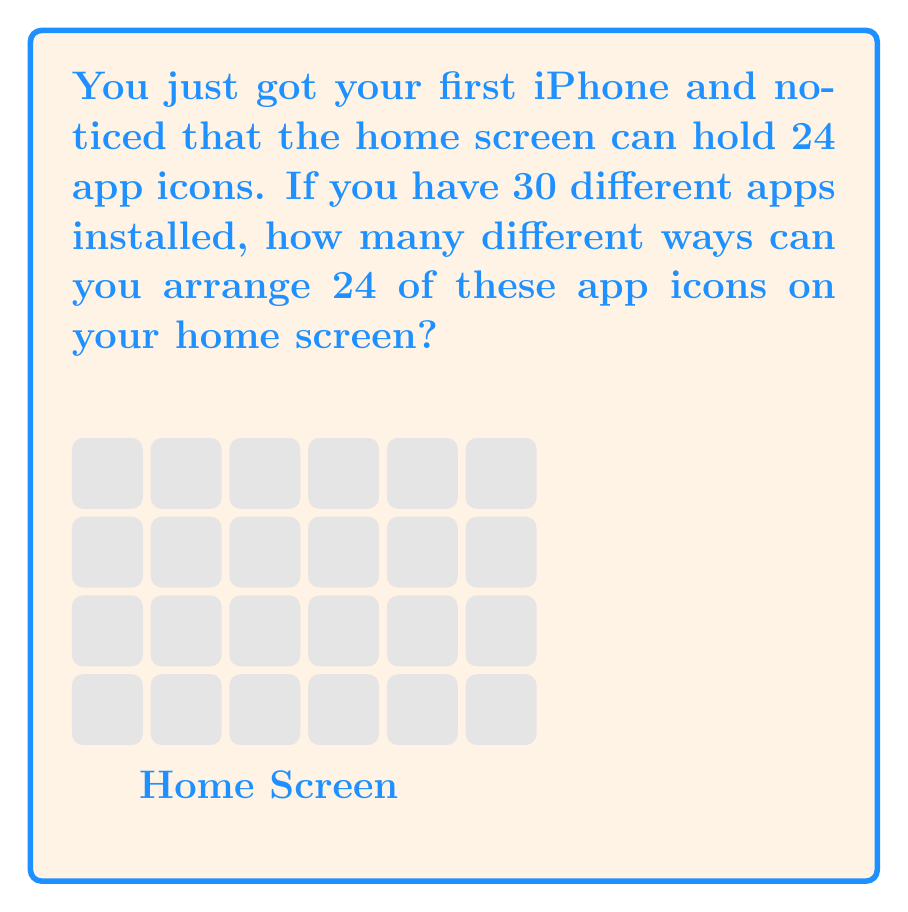Could you help me with this problem? Let's break this down step-by-step:

1) First, we need to understand what the question is asking. We're selecting 24 apps out of 30 and arranging them on the screen.

2) This is a combination of two operations:
   a) Choosing 24 apps out of 30
   b) Arranging these 24 apps

3) For choosing 24 apps out of 30, we use the combination formula:

   $$\binom{30}{24} = \frac{30!}{24!(30-24)!} = \frac{30!}{24!6!}$$

4) After choosing the apps, we need to arrange them. This is a permutation of 24 items, which is simply 24!

5) By the multiplication principle, we multiply these two operations:

   $$\binom{30}{24} \times 24!$$

6) Let's calculate:
   
   $$\frac{30!}{24!6!} \times 24! = \frac{30!}{6!}$$

7) This can be written as:

   $$30 \times 29 \times 28 \times 27 \times 26 \times 25$$

8) Multiplying these numbers:

   $$30 \times 29 \times 28 \times 27 \times 26 \times 25 = 427,518,000$$

Therefore, there are 427,518,000 different ways to arrange 24 app icons out of 30 apps on your iPhone home screen.
Answer: 427,518,000 